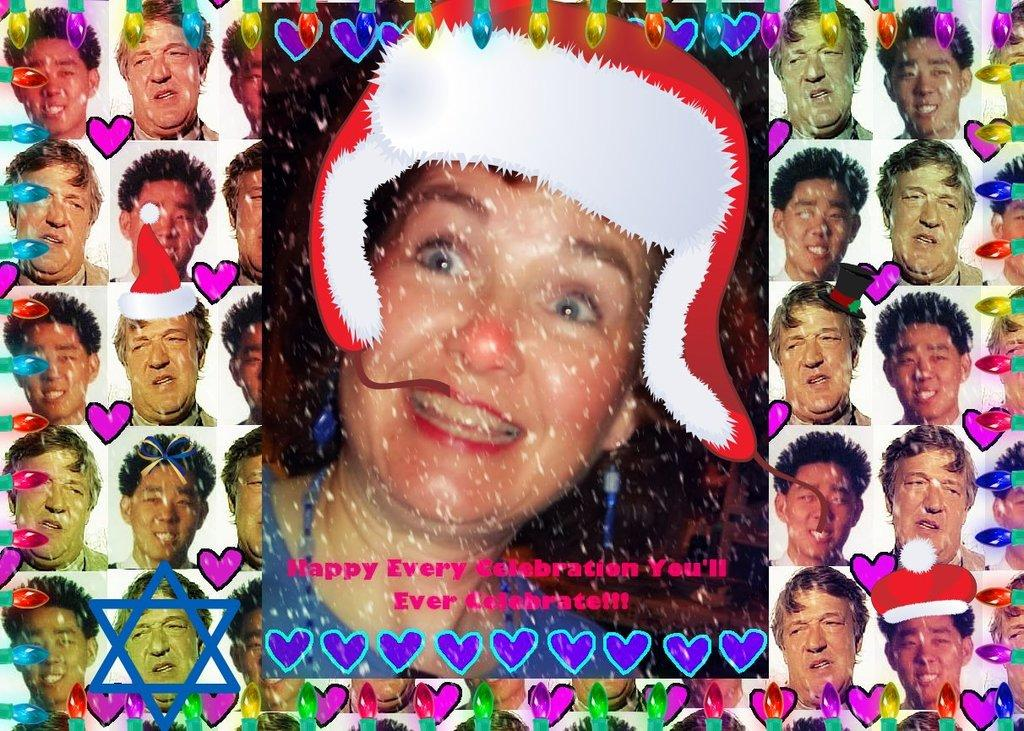What type of images are present in the collage? The collage contains pictures of a person. Can you describe the style or format of the images? The images are in a collage format, which means they are arranged together in a creative or artistic way. What type of army is depicted in the collage? There is no army present in the collage; it contains pictures of a person. What flavor of ice cream is associated with the person in the collage? There is no mention of ice cream or flavors in the image or the provided facts. 